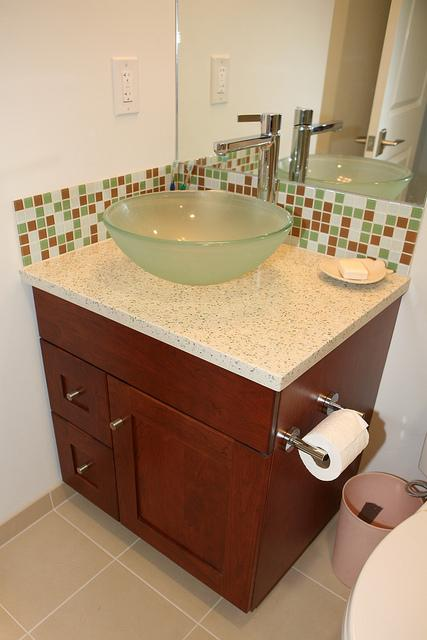What is the green bowl on the counter used for? washing hands 